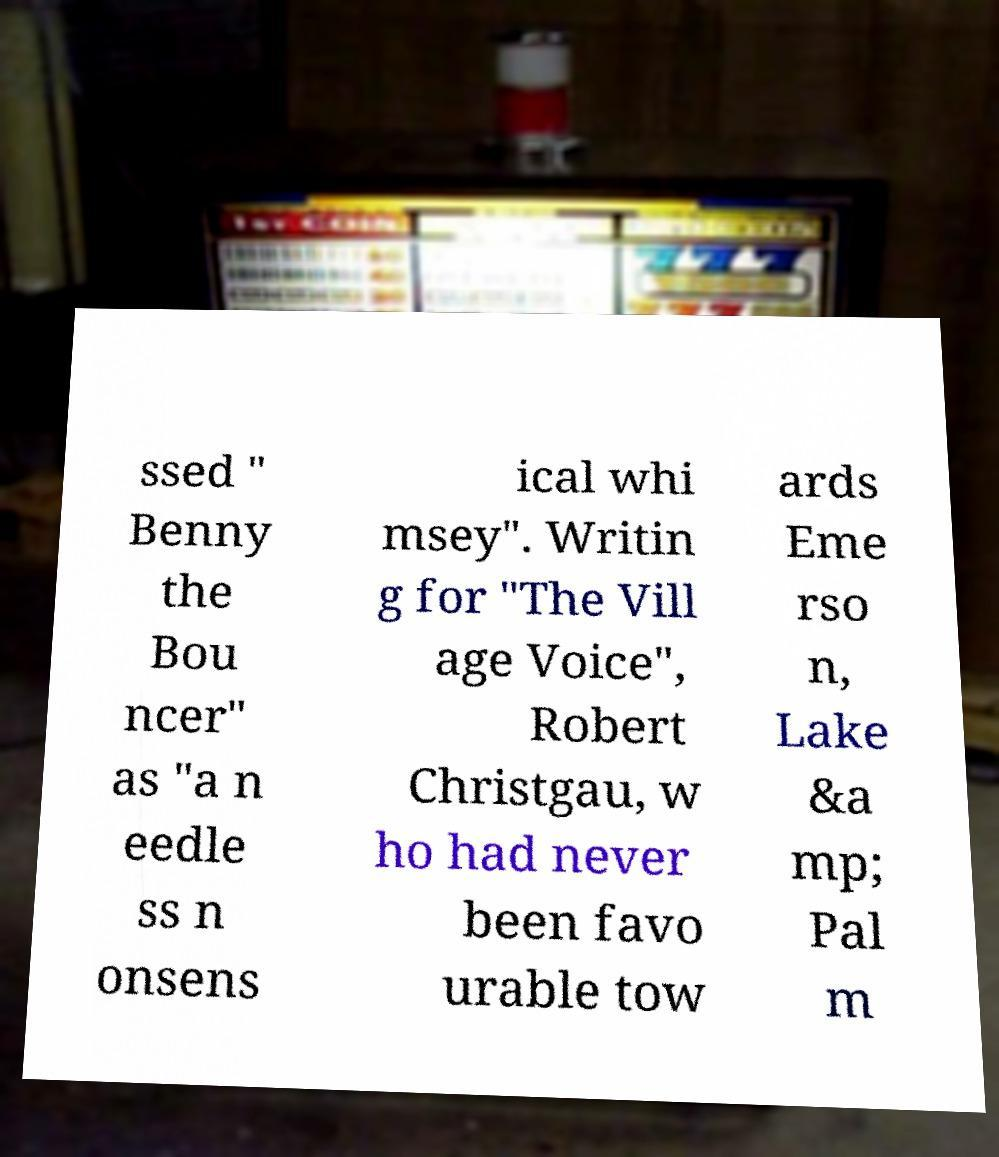I need the written content from this picture converted into text. Can you do that? ssed " Benny the Bou ncer" as "a n eedle ss n onsens ical whi msey". Writin g for "The Vill age Voice", Robert Christgau, w ho had never been favo urable tow ards Eme rso n, Lake &a mp; Pal m 